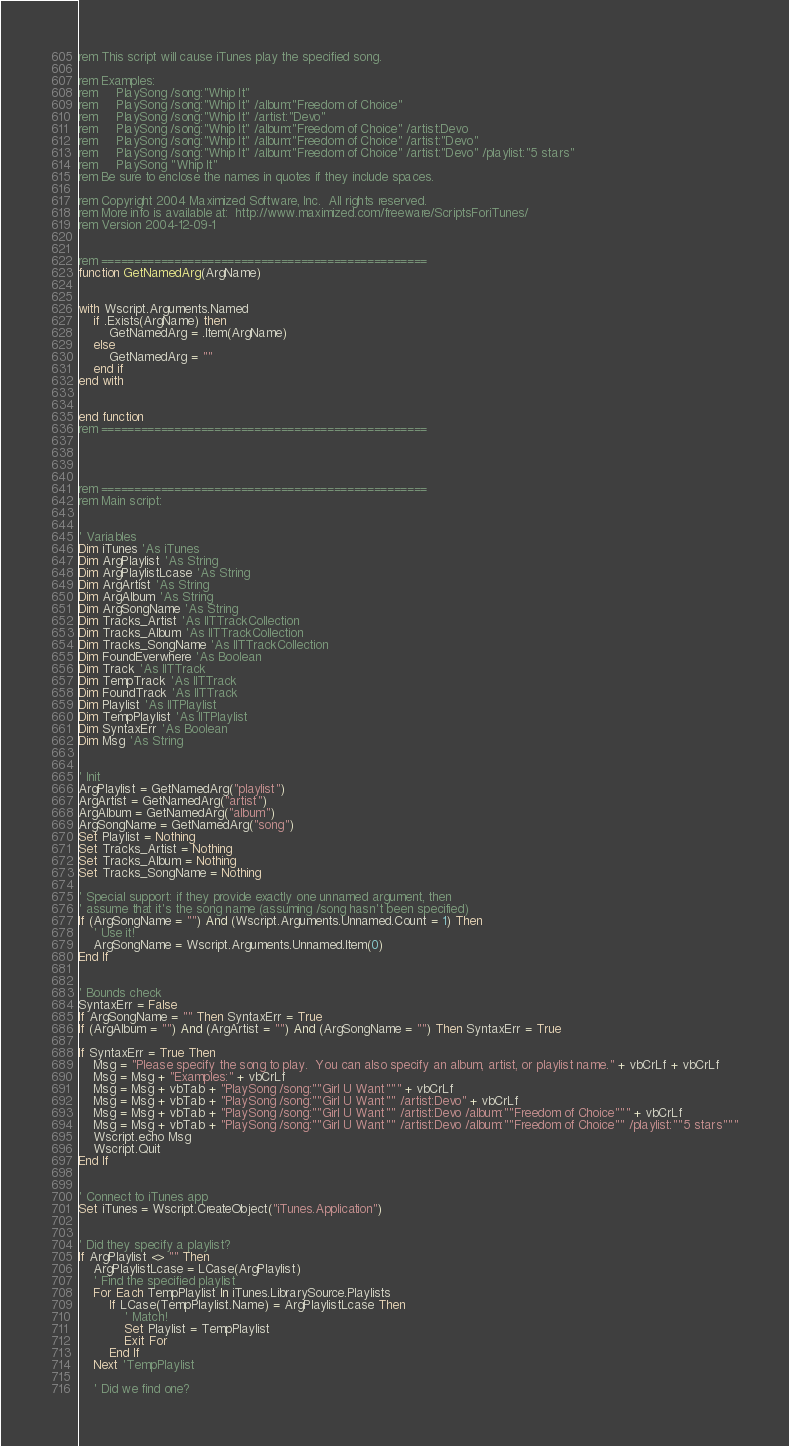Convert code to text. <code><loc_0><loc_0><loc_500><loc_500><_VisualBasic_>rem This script will cause iTunes play the specified song.

rem Examples:
rem	    PlaySong /song:"Whip It"
rem	    PlaySong /song:"Whip It" /album:"Freedom of Choice"
rem	    PlaySong /song:"Whip It" /artist:"Devo"
rem	    PlaySong /song:"Whip It" /album:"Freedom of Choice" /artist:Devo
rem	    PlaySong /song:"Whip It" /album:"Freedom of Choice" /artist:"Devo"
rem	    PlaySong /song:"Whip It" /album:"Freedom of Choice" /artist:"Devo" /playlist:"5 stars"
rem		PlaySong "Whip It"
rem Be sure to enclose the names in quotes if they include spaces.

rem Copyright 2004 Maximized Software, Inc.  All rights reserved.
rem More info is available at:  http://www.maximized.com/freeware/ScriptsForiTunes/
rem Version 2004-12-09-1


rem =================================================
function GetNamedArg(ArgName)


with Wscript.Arguments.Named
	if .Exists(ArgName) then
		GetNamedArg = .Item(ArgName)
	else
		GetNamedArg = ""
	end if
end with


end function
rem =================================================




rem =================================================
rem Main script:


' Variables
Dim iTunes 'As iTunes
Dim ArgPlaylist 'As String
Dim ArgPlaylistLcase 'As String
Dim ArgArtist 'As String
Dim ArgAlbum 'As String
Dim ArgSongName 'As String
Dim Tracks_Artist 'As IITTrackCollection
Dim Tracks_Album 'As IITTrackCollection
Dim Tracks_SongName 'As IITTrackCollection
Dim FoundEverwhere 'As Boolean
Dim Track 'As IITTrack
Dim TempTrack 'As IITTrack
Dim FoundTrack 'As IITTrack
Dim Playlist 'As IITPlaylist
Dim TempPlaylist 'As IITPlaylist
Dim SyntaxErr 'As Boolean
Dim Msg 'As String


' Init
ArgPlaylist = GetNamedArg("playlist")
ArgArtist = GetNamedArg("artist")
ArgAlbum = GetNamedArg("album")
ArgSongName = GetNamedArg("song")
Set Playlist = Nothing
Set Tracks_Artist = Nothing
Set Tracks_Album = Nothing
Set Tracks_SongName = Nothing

' Special support: if they provide exactly one unnamed argument, then
' assume that it's the song name (assuming /song hasn't been specified)
If (ArgSongName = "") And (Wscript.Arguments.Unnamed.Count = 1) Then
	' Use it!
	ArgSongName = Wscript.Arguments.Unnamed.Item(0)
End If


' Bounds check
SyntaxErr = False
If ArgSongName = "" Then SyntaxErr = True
If (ArgAlbum = "") And (ArgArtist = "") And (ArgSongName = "") Then SyntaxErr = True

If SyntaxErr = True Then
    Msg = "Please specify the song to play.  You can also specify an album, artist, or playlist name." + vbCrLf + vbCrLf
	Msg = Msg + "Examples:" + vbCrLf
	Msg = Msg + vbTab + "PlaySong /song:""Girl U Want""" + vbCrLf
	Msg = Msg + vbTab + "PlaySong /song:""Girl U Want"" /artist:Devo" + vbCrLf
	Msg = Msg + vbTab + "PlaySong /song:""Girl U Want"" /artist:Devo /album:""Freedom of Choice""" + vbCrLf
	Msg = Msg + vbTab + "PlaySong /song:""Girl U Want"" /artist:Devo /album:""Freedom of Choice"" /playlist:""5 stars"""
    Wscript.echo Msg
    Wscript.Quit
End If


' Connect to iTunes app
Set iTunes = Wscript.CreateObject("iTunes.Application")


' Did they specify a playlist?
If ArgPlaylist <> "" Then
    ArgPlaylistLcase = LCase(ArgPlaylist)
    ' Find the specified playlist
    For Each TempPlaylist In iTunes.LibrarySource.Playlists
        If LCase(TempPlaylist.Name) = ArgPlaylistLcase Then
            ' Match!
            Set Playlist = TempPlaylist
            Exit For
        End If
    Next 'TempPlaylist

    ' Did we find one?</code> 